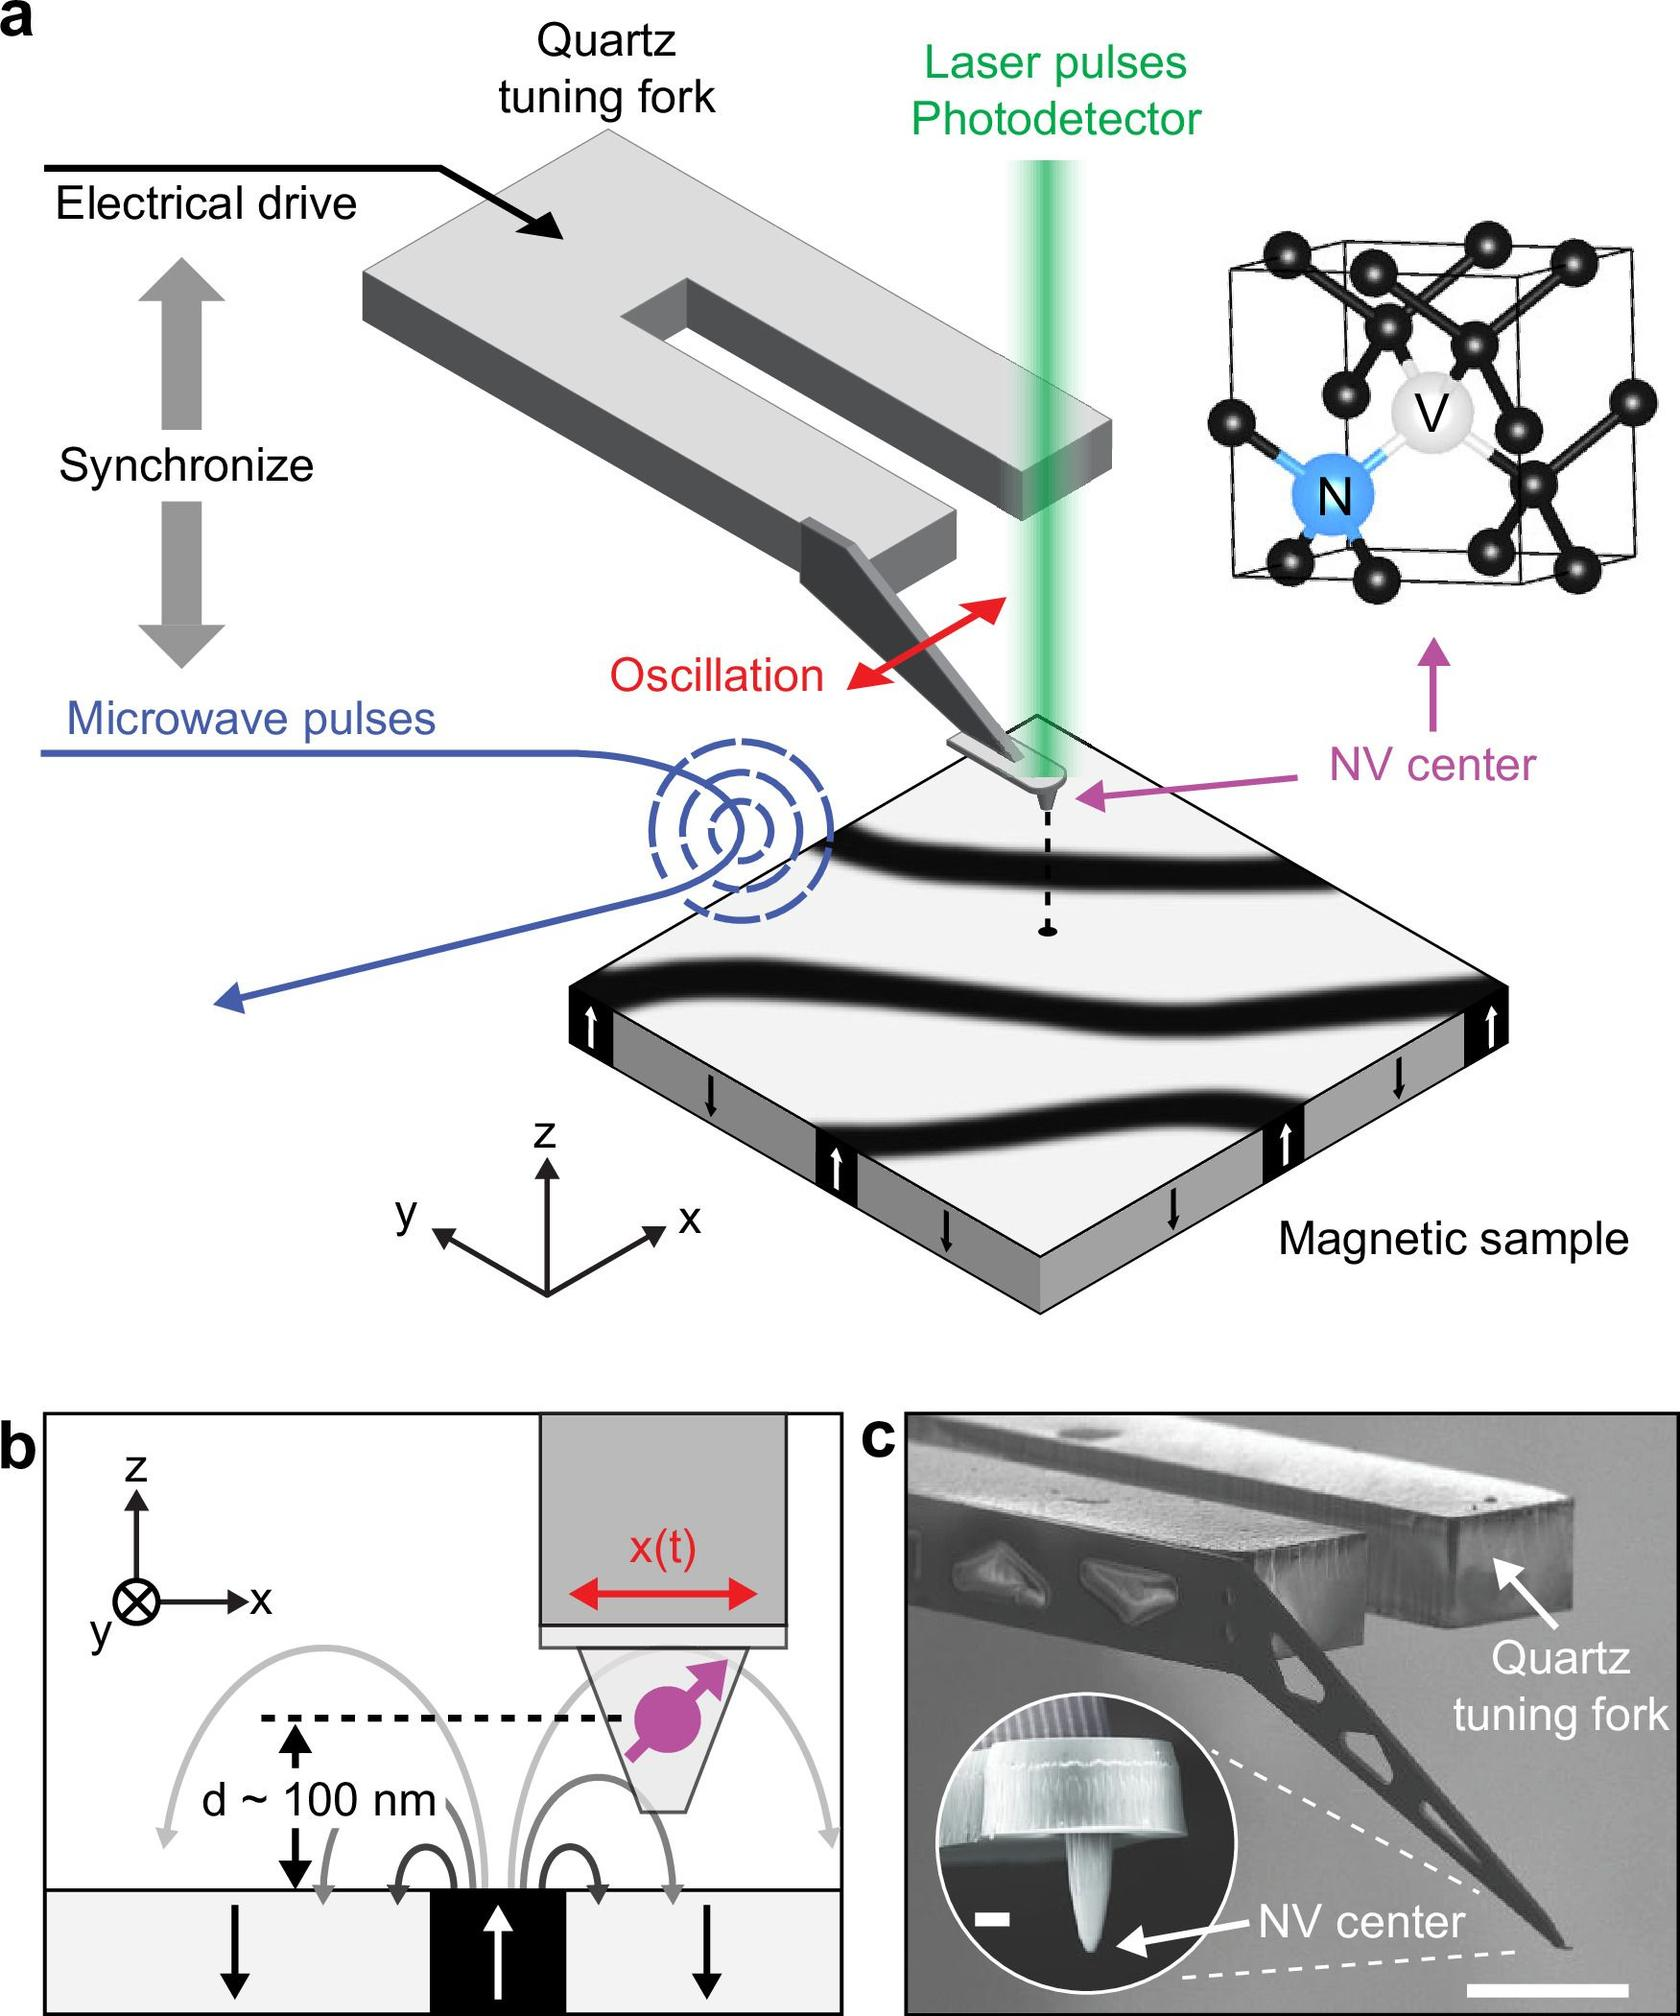Can you explain what an NV center is and why it is important in this experimental context? An NV center, or nitrogen-vacancy center, is a type of point defect in a diamond lattice, where a nitrogen atom replaces a carbon atom adjacent to a vacancy. In this experimental context, the NV center is important because its electronic spin state can be manipulated and read out using microwave and laser pulses, making it a powerful sensor for magnetic fields at the nanoscale. 